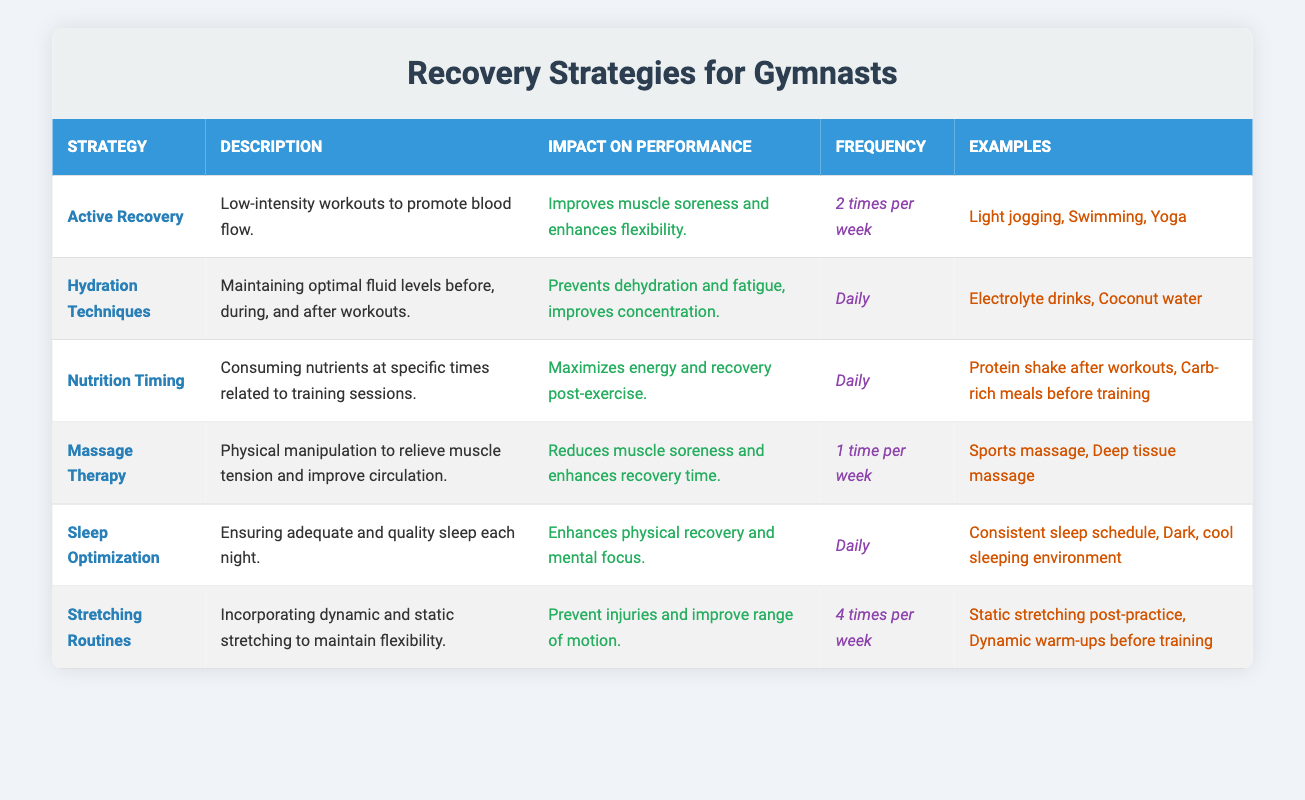What is the frequency of Active Recovery per week? The frequency for Active Recovery is listed in the "Frequency" column of the table, which states it is performed 2 times per week.
Answer: 2 times per week What is the impact on performance of Sleep Optimization? In the table, the impact on performance for Sleep Optimization is described as enhancing physical recovery and mental focus.
Answer: Enhances physical recovery and mental focus True or False: Massage Therapy is recommended to be done daily. In the table, it states that Massage Therapy is done 1 time per week, which means it is not recommended daily.
Answer: False Which recovery strategy has the highest frequency per week? Looking through the table, the strategy with the highest frequency is Stretching Routines at 4 times per week.
Answer: Stretching Routines What are the example exercises for Active Recovery? The "Examples" column for Active Recovery lists "Light jogging, Swimming, Yoga" as the example exercises.
Answer: Light jogging, Swimming, Yoga If a gymnast follows both Hydration Techniques and Nutrition Timing daily, how many total times per week are these strategies practiced? Both strategies are practiced daily, which counts as 7 days for each. Therefore, the total is 7 + 7 = 14 times per week.
Answer: 14 times per week What is the combined impact on performance of Active Recovery and Stretching Routines? The impact of Active Recovery is to improve muscle soreness and enhance flexibility, while Stretching Routines help prevent injuries and improve range of motion. Together, they focus on muscle recovery and flexibility.
Answer: Muscle recovery and flexibility Which recovery strategy focuses on nutrient timing relative to training sessions? The table indicates that Nutrition Timing has a description focusing on consuming nutrients at specific times related to training sessions.
Answer: Nutrition Timing What is the frequency of both Sleep Optimization and Nutrition Timing? In the table, both Sleep Optimization and Nutrition Timing are practiced daily which indicates they are done 7 times per week each.
Answer: Daily (7 times per week) 